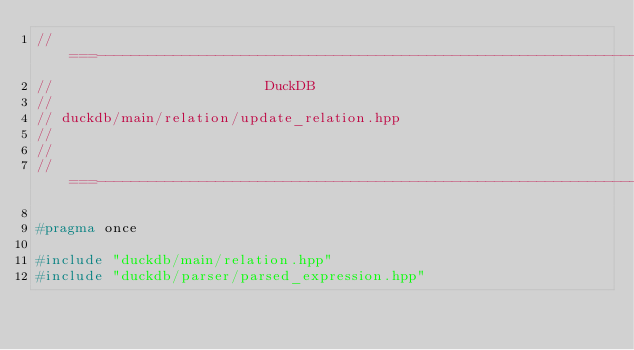Convert code to text. <code><loc_0><loc_0><loc_500><loc_500><_C++_>//===----------------------------------------------------------------------===//
//                         DuckDB
//
// duckdb/main/relation/update_relation.hpp
//
//
//===----------------------------------------------------------------------===//

#pragma once

#include "duckdb/main/relation.hpp"
#include "duckdb/parser/parsed_expression.hpp"
</code> 